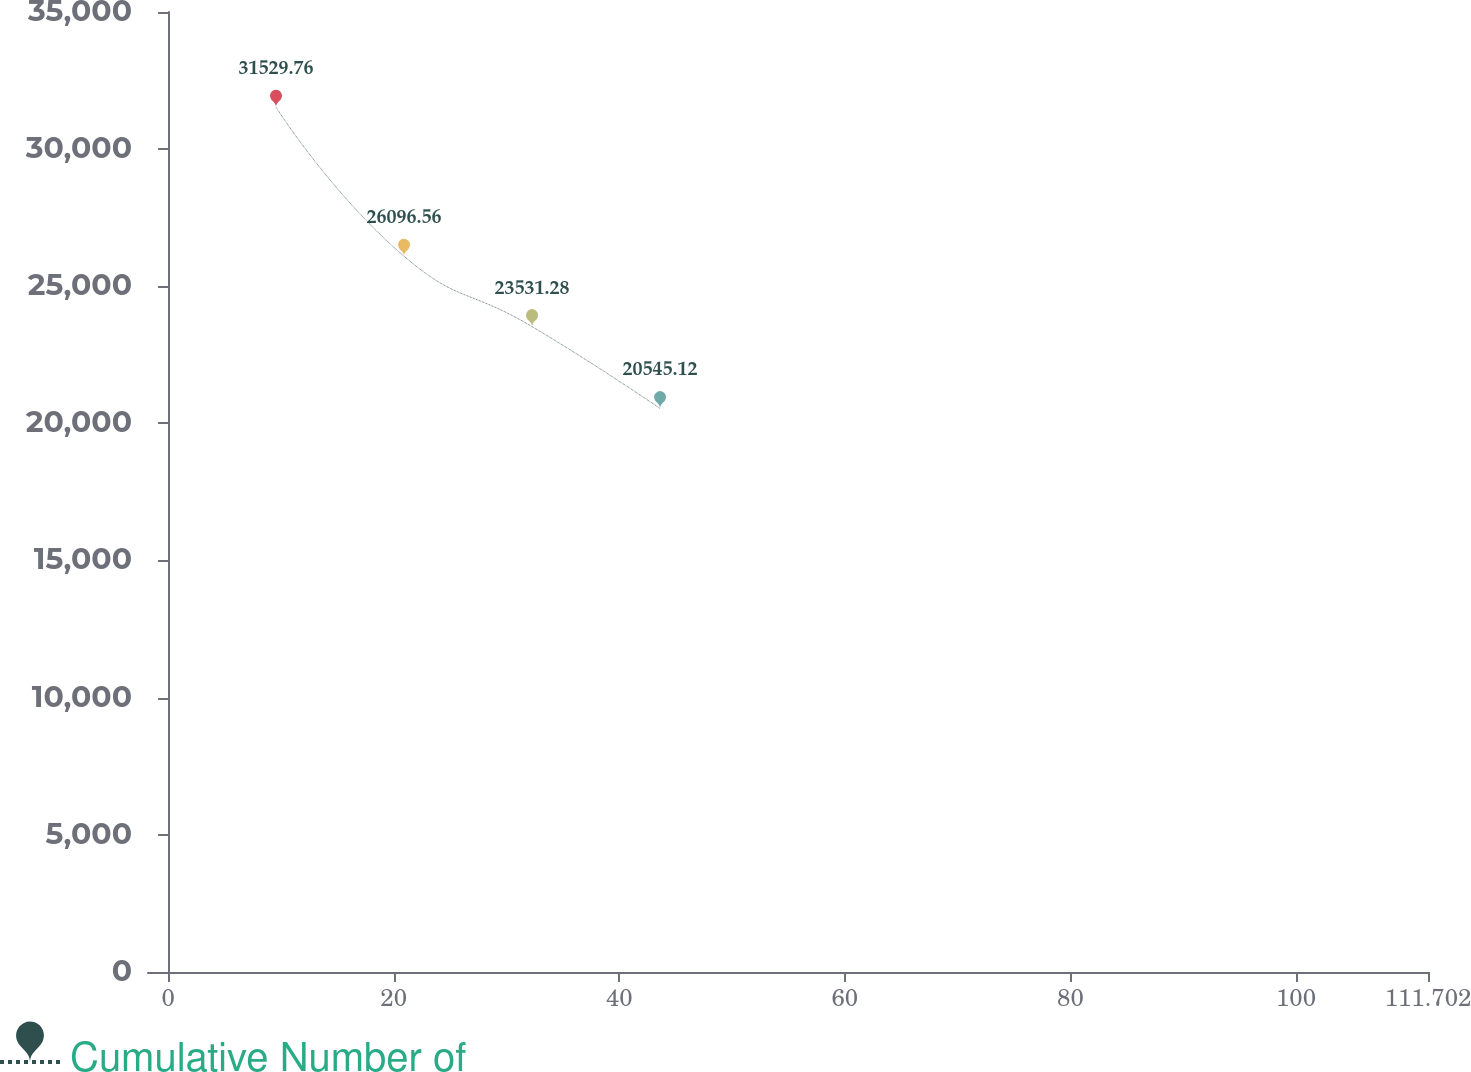Convert chart. <chart><loc_0><loc_0><loc_500><loc_500><line_chart><ecel><fcel>Cumulative Number of<nl><fcel>9.57<fcel>31529.8<nl><fcel>20.92<fcel>26096.6<nl><fcel>32.27<fcel>23531.3<nl><fcel>43.62<fcel>20545.1<nl><fcel>123.05<fcel>19324.6<nl></chart> 